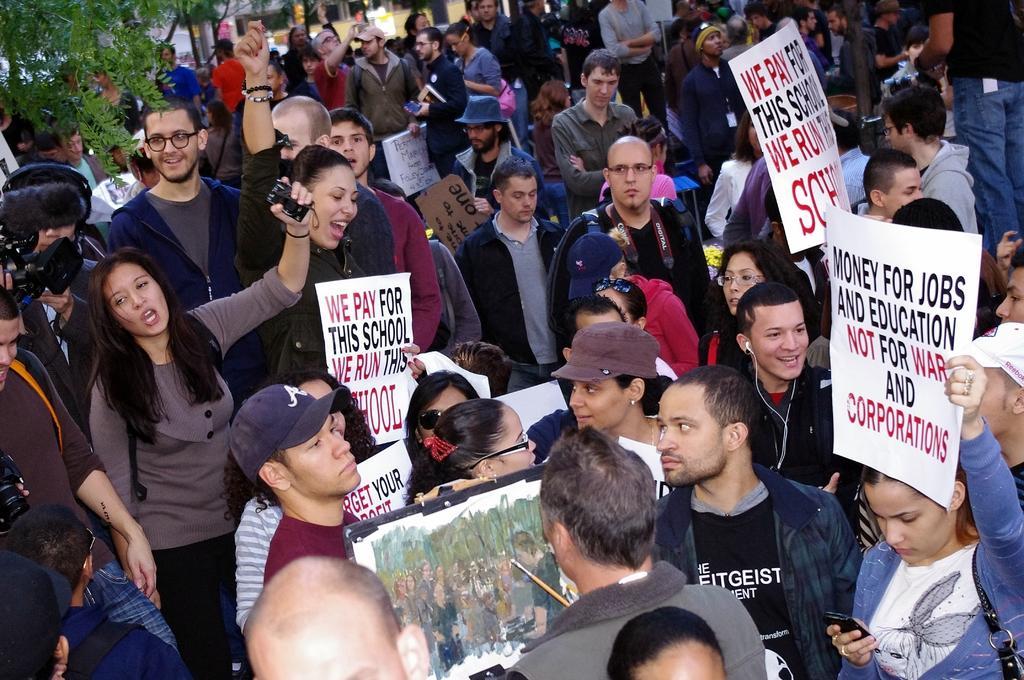In one or two sentences, can you explain what this image depicts? In the picture I can see few people are holding placards in their hands on which we can see some text is written. Here we can see a person holding paint brush and painting on the board. On the left side of the image we can see a person holding video camera and we can see a tree. 